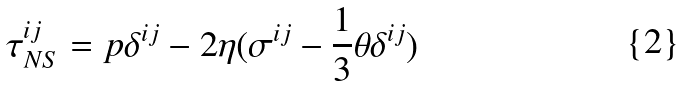Convert formula to latex. <formula><loc_0><loc_0><loc_500><loc_500>\tau ^ { i j } _ { N S } = p \delta ^ { i j } - 2 \eta ( \sigma ^ { i j } - \frac { 1 } { 3 } \theta \delta ^ { i j } )</formula> 